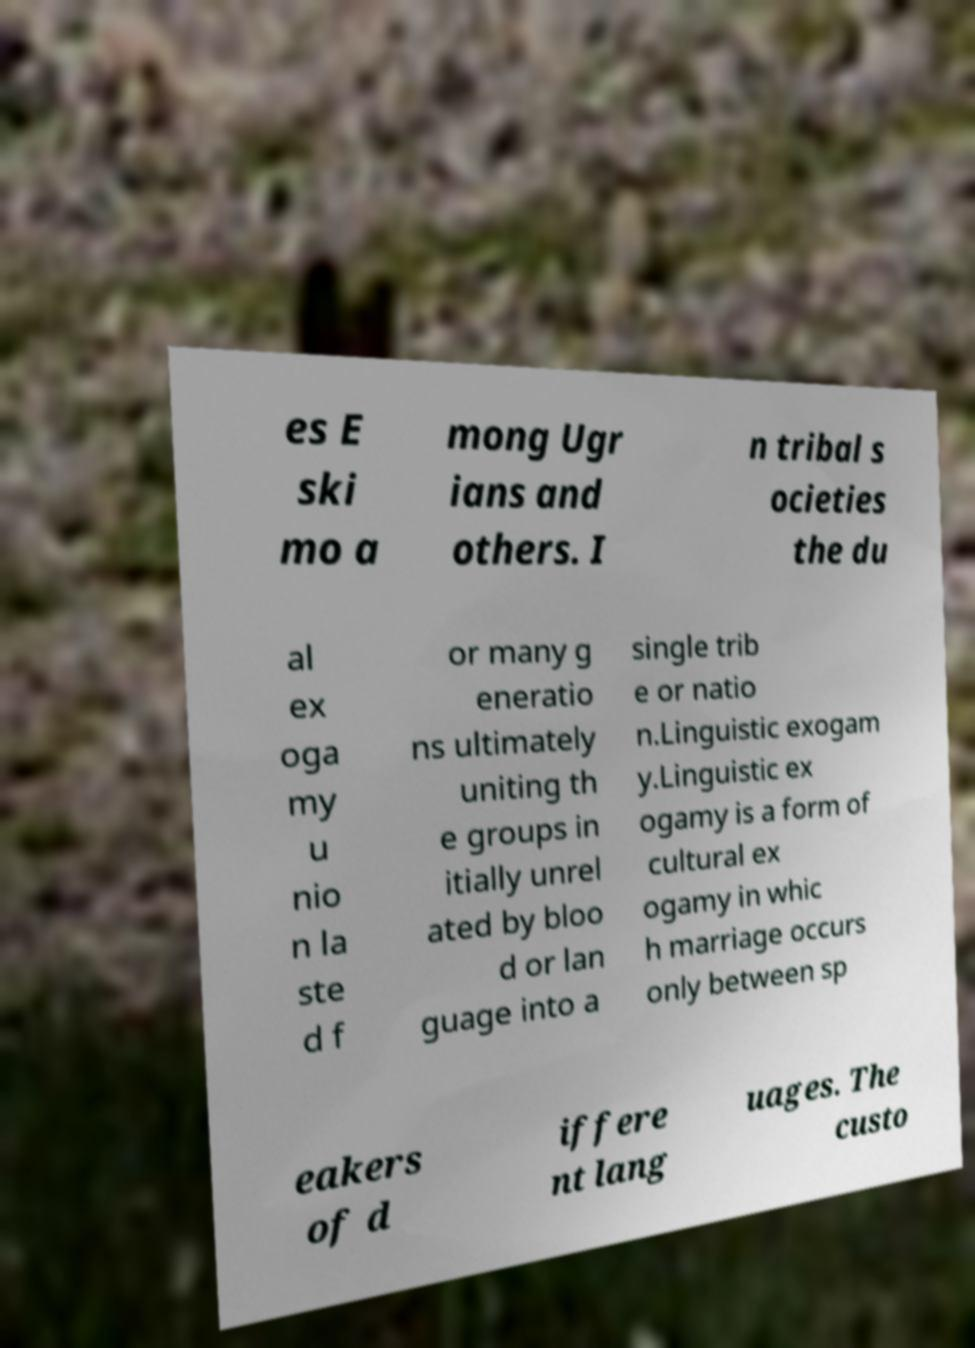Can you read and provide the text displayed in the image?This photo seems to have some interesting text. Can you extract and type it out for me? es E ski mo a mong Ugr ians and others. I n tribal s ocieties the du al ex oga my u nio n la ste d f or many g eneratio ns ultimately uniting th e groups in itially unrel ated by bloo d or lan guage into a single trib e or natio n.Linguistic exogam y.Linguistic ex ogamy is a form of cultural ex ogamy in whic h marriage occurs only between sp eakers of d iffere nt lang uages. The custo 